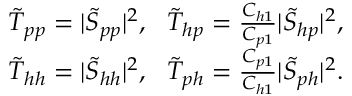Convert formula to latex. <formula><loc_0><loc_0><loc_500><loc_500>\begin{array} { r l r } & { \tilde { T } _ { p p } = | \tilde { S } _ { p p } | ^ { 2 } , \tilde { T } _ { h p } = \frac { C _ { h 1 } } { C _ { p 1 } } | \tilde { S } _ { h p } | ^ { 2 } , } \\ & { \tilde { T } _ { h h } = | \tilde { S } _ { h h } | ^ { 2 } , \tilde { T } _ { p h } = \frac { C _ { p 1 } } { C _ { h 1 } } | \tilde { S } _ { p h } | ^ { 2 } . } \end{array}</formula> 